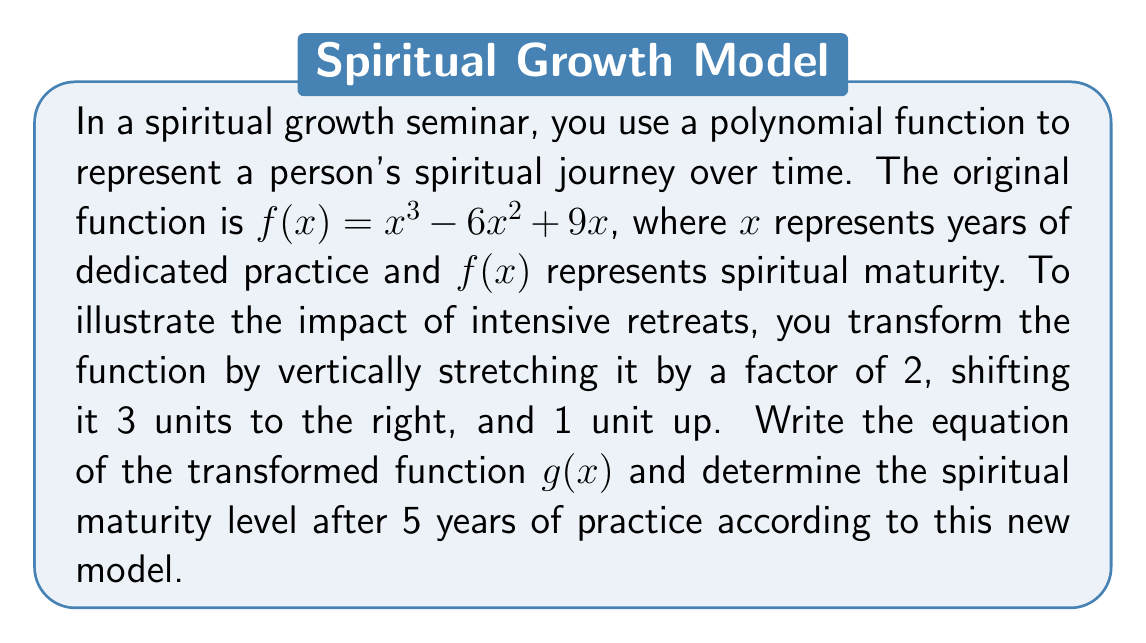Teach me how to tackle this problem. Let's approach this step-by-step:

1) The original function is $f(x) = x^3 - 6x^2 + 9x$

2) To transform the function:
   a) Vertical stretch by factor of 2: $2f(x)$
   b) Shift 3 units right: Replace all $x$ with $(x-3)$
   c) Shift 1 unit up: Add 1 to the entire function

3) Applying these transformations:
   $g(x) = 2f(x-3) + 1$

4) Expand this:
   $g(x) = 2[(x-3)^3 - 6(x-3)^2 + 9(x-3)] + 1$

5) Simplify:
   $g(x) = 2[x^3 - 9x^2 + 27x - 27 - 6x^2 + 36x - 54 + 9x - 27] + 1$
   $g(x) = 2[x^3 - 15x^2 + 72x - 108] + 1$
   $g(x) = 2x^3 - 30x^2 + 144x - 216 + 1$
   $g(x) = 2x^3 - 30x^2 + 144x - 215$

6) To find the spiritual maturity level after 5 years, calculate $g(5)$:
   $g(5) = 2(5^3) - 30(5^2) + 144(5) - 215$
   $g(5) = 2(125) - 30(25) + 144(5) - 215$
   $g(5) = 250 - 750 + 720 - 215$
   $g(5) = 5$

Therefore, after 5 years of practice, the spiritual maturity level according to this new model is 5 units.
Answer: The transformed function is $g(x) = 2x^3 - 30x^2 + 144x - 215$, and the spiritual maturity level after 5 years of practice is 5 units. 